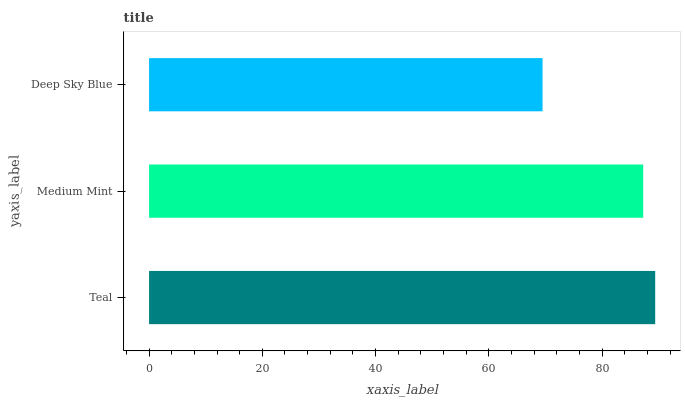Is Deep Sky Blue the minimum?
Answer yes or no. Yes. Is Teal the maximum?
Answer yes or no. Yes. Is Medium Mint the minimum?
Answer yes or no. No. Is Medium Mint the maximum?
Answer yes or no. No. Is Teal greater than Medium Mint?
Answer yes or no. Yes. Is Medium Mint less than Teal?
Answer yes or no. Yes. Is Medium Mint greater than Teal?
Answer yes or no. No. Is Teal less than Medium Mint?
Answer yes or no. No. Is Medium Mint the high median?
Answer yes or no. Yes. Is Medium Mint the low median?
Answer yes or no. Yes. Is Deep Sky Blue the high median?
Answer yes or no. No. Is Teal the low median?
Answer yes or no. No. 